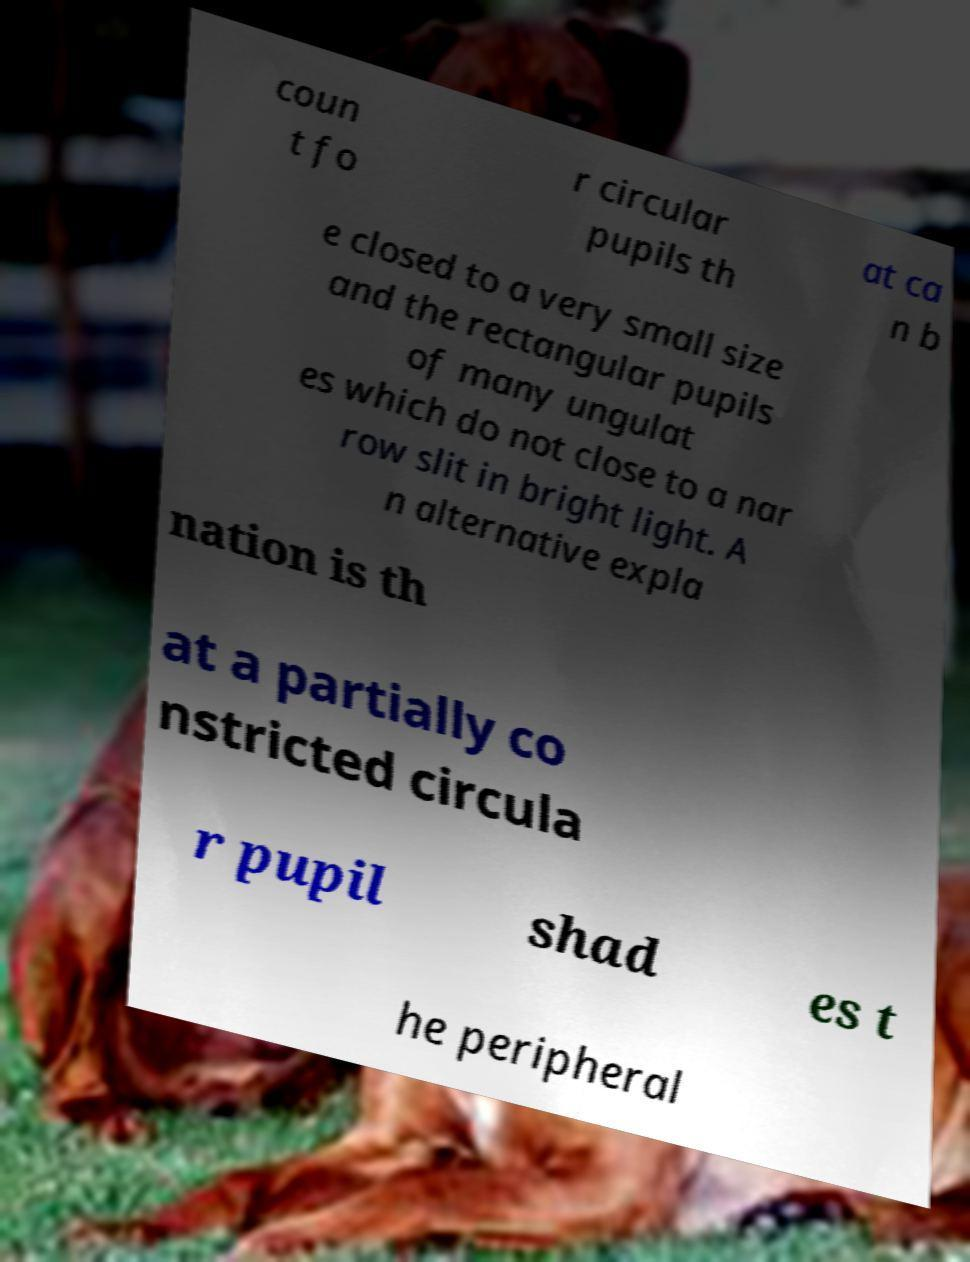For documentation purposes, I need the text within this image transcribed. Could you provide that? coun t fo r circular pupils th at ca n b e closed to a very small size and the rectangular pupils of many ungulat es which do not close to a nar row slit in bright light. A n alternative expla nation is th at a partially co nstricted circula r pupil shad es t he peripheral 